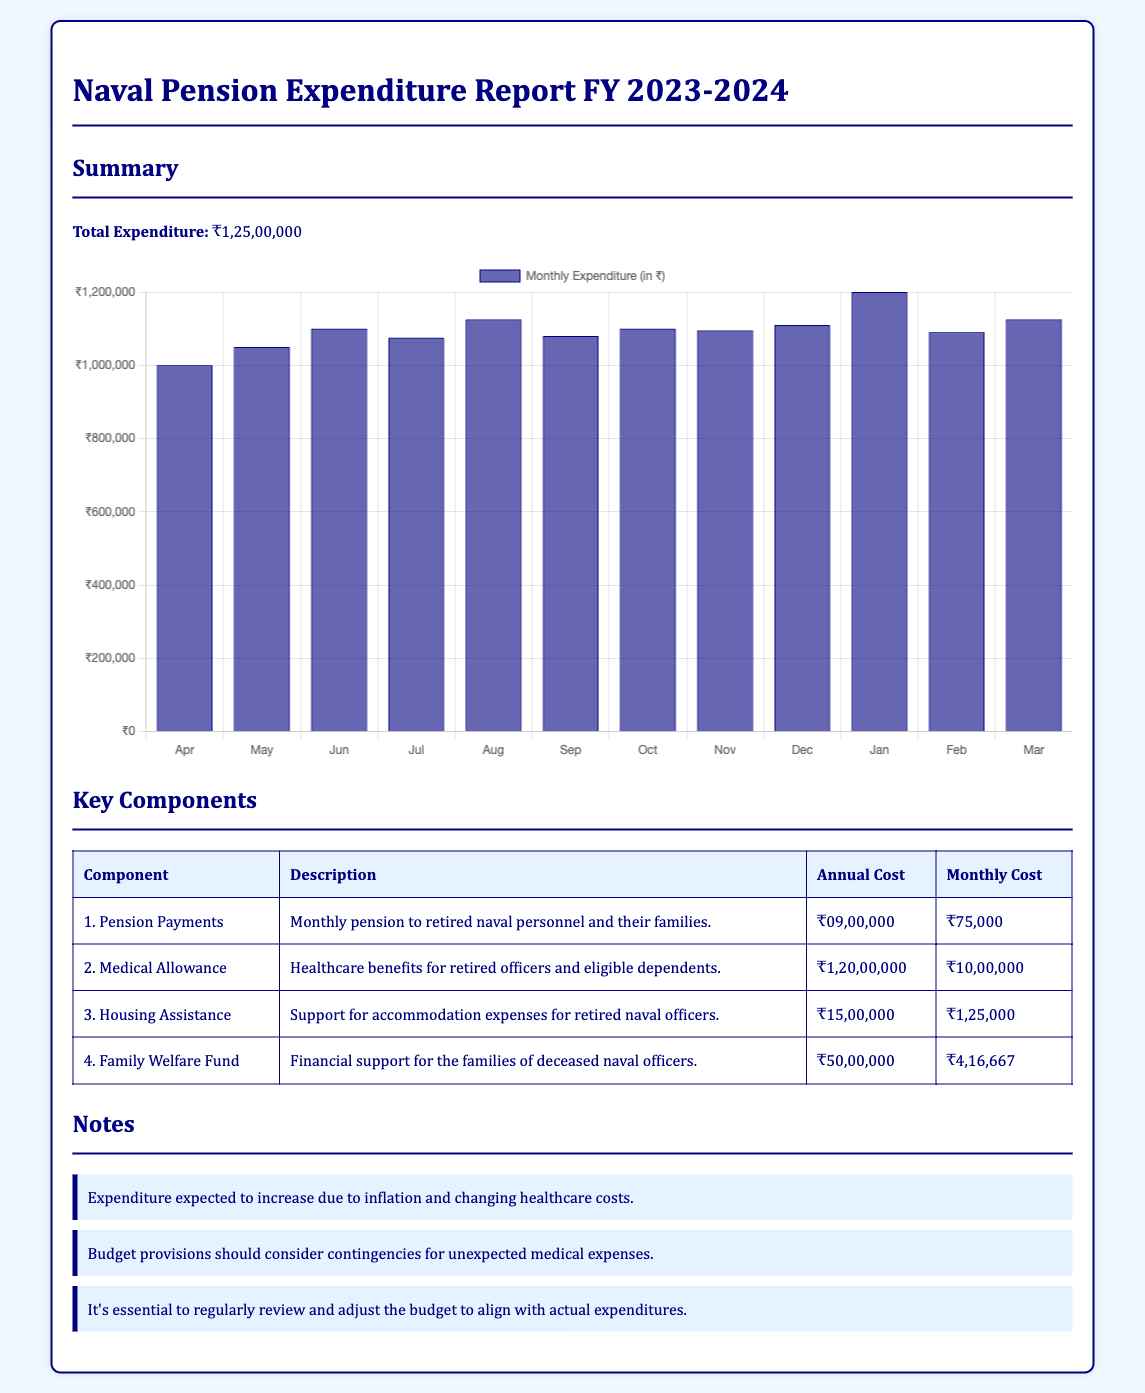What is the total expenditure? The total expenditure is provided in the summary section of the document.
Answer: ₹1,25,00,000 What is the monthly cost for medical allowance? The monthly cost for medical allowance is listed in the key components table.
Answer: ₹10,00,000 What component has the highest annual cost? By comparing the annual costs in the key components table, we can identify which one is the highest.
Answer: Medical Allowance What is the monthly cost for pension payments? This information is found in the key components, specifically under pension payments.
Answer: ₹75,000 What is the total annual cost for housing assistance? The annual cost for housing assistance is detailed in the key components section.
Answer: ₹15,00,000 How many months is the expenditure data provided for in the chart? The chart lists monthly expenditure for each month of the fiscal year.
Answer: 12 months What is the expenditure for the month of January? The monthly expenditure data is indicated in the chart, specifically for January.
Answer: ₹12,00,000 What is the average monthly expenditure? To find the average, the total expenditure divided by the number of months in the fiscal year is used.
Answer: ₹10,41,667 What is the purpose of the Family Welfare Fund? This information can be found that describes the Family Welfare Fund in the key components section.
Answer: Financial support for deceased naval officers' families What should the budget consider according to the notes section? The notes section mentions specific considerations for preparing the budget.
Answer: Contingencies for unexpected medical expenses 